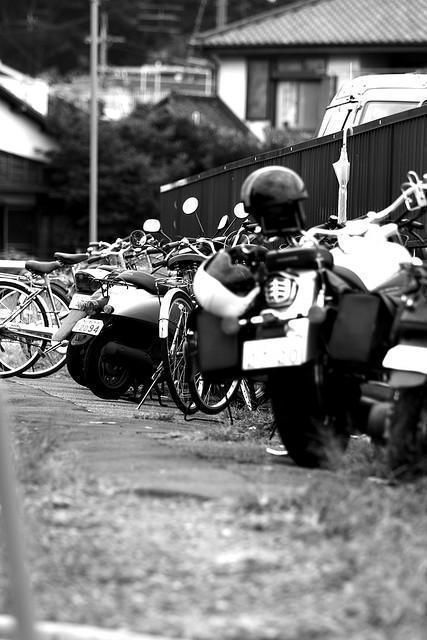What kind of transportation is shown?
Choose the right answer from the provided options to respond to the question.
Options: Water, road, air, rail. Road. 